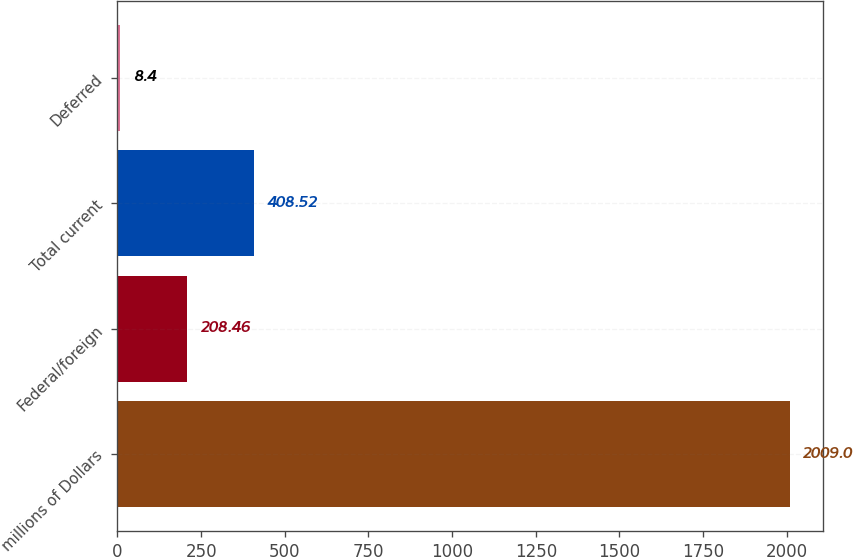Convert chart to OTSL. <chart><loc_0><loc_0><loc_500><loc_500><bar_chart><fcel>millions of Dollars<fcel>Federal/foreign<fcel>Total current<fcel>Deferred<nl><fcel>2009<fcel>208.46<fcel>408.52<fcel>8.4<nl></chart> 